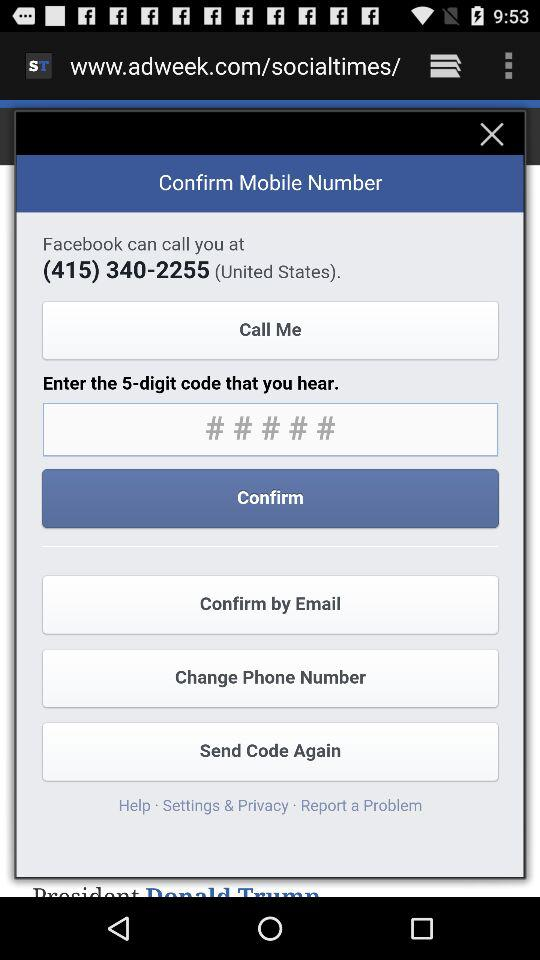What is the 5-digit code?
When the provided information is insufficient, respond with <no answer>. <no answer> 